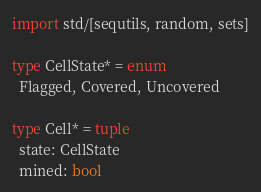<code> <loc_0><loc_0><loc_500><loc_500><_Nim_>import std/[sequtils, random, sets]

type CellState* = enum
  Flagged, Covered, Uncovered

type Cell* = tuple
  state: CellState
  mined: bool
</code> 